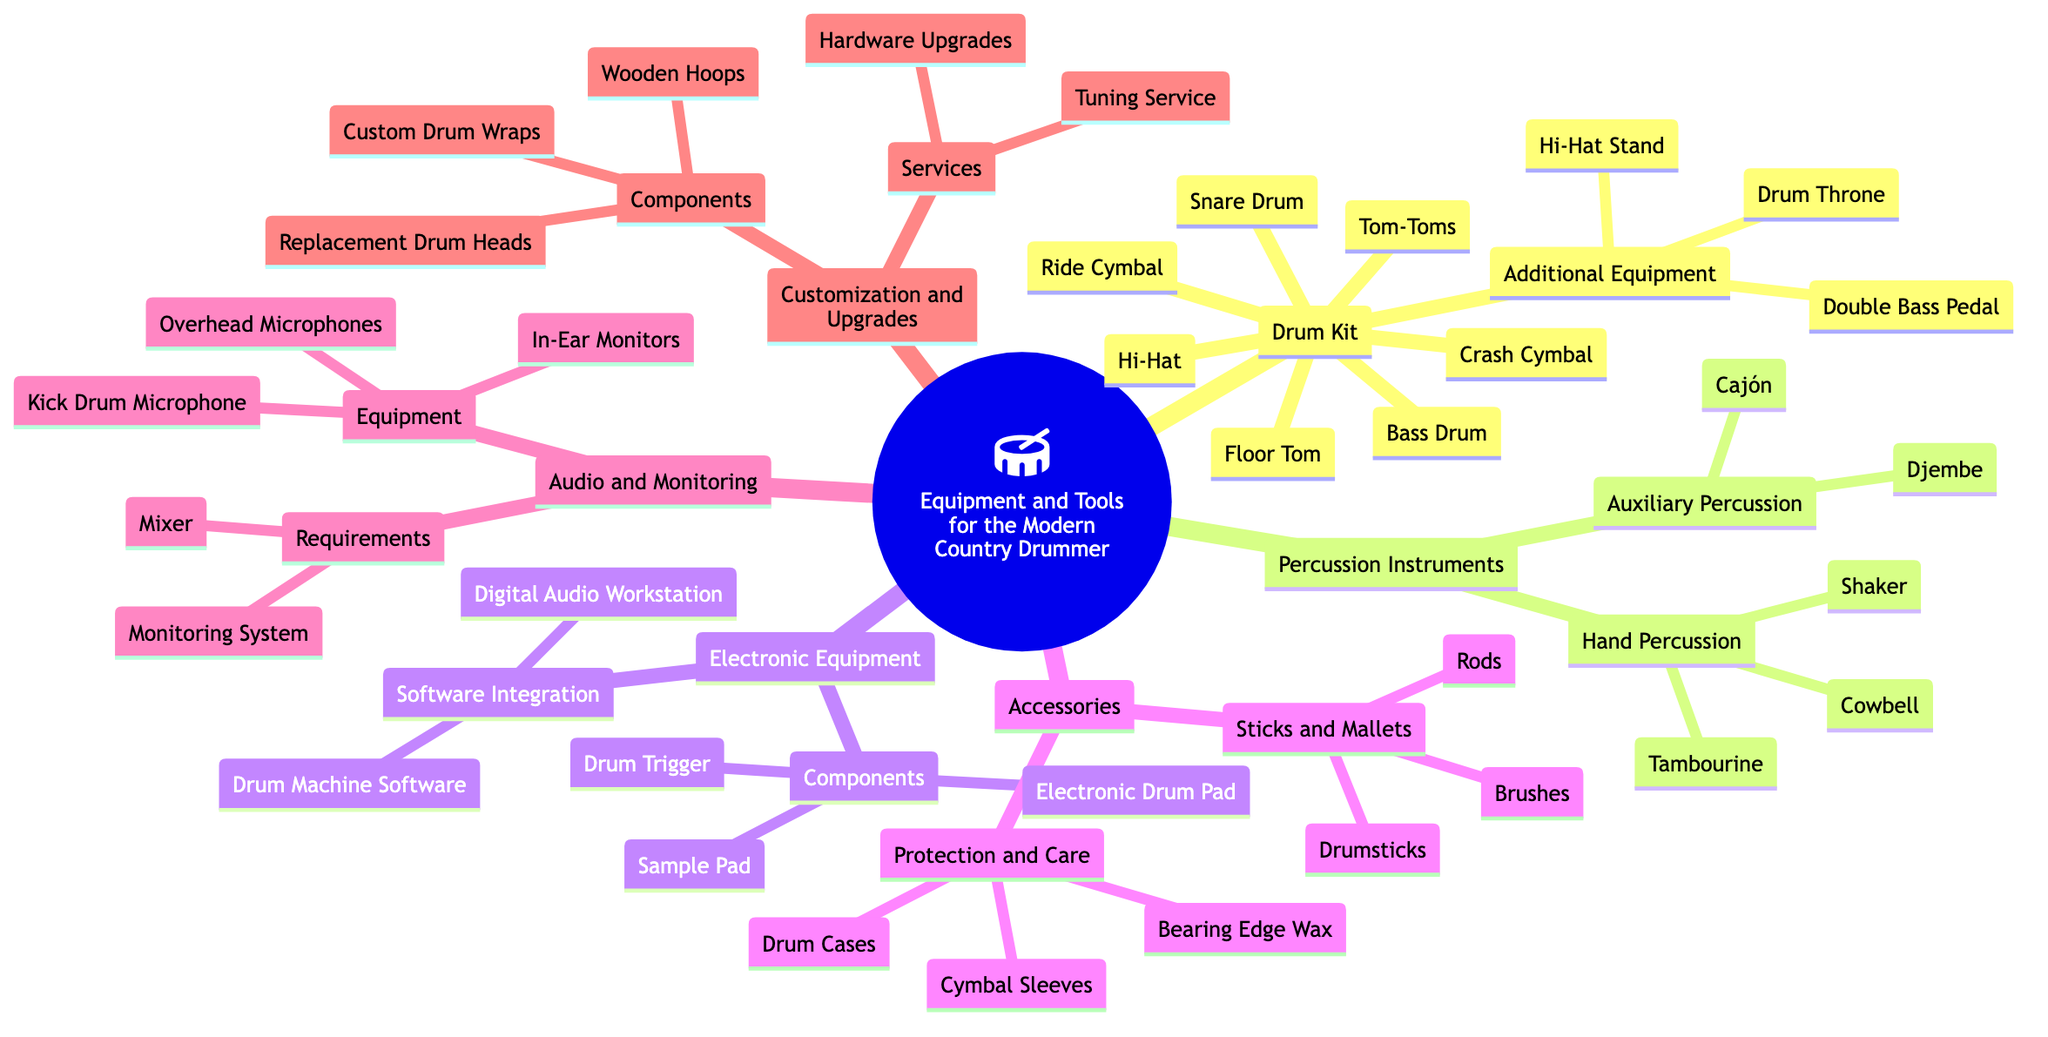What are the main categories of equipment listed in the mind map? The mind map lists "Drum Kit", "Percussion Instruments", "Electronic Equipment", "Accessories", "Audio and Monitoring", and "Customization and Upgrades" as main categories. These categories can be found as the primary nodes branching out from the root node.
Answer: Drum Kit, Percussion Instruments, Electronic Equipment, Accessories, Audio and Monitoring, Customization and Upgrades How many components are included in the "Drum Kit"? The "Drum Kit" sub-topic includes seven components: "Snare Drum", "Bass Drum", "Tom-Toms", "Hi-Hat", "Ride Cymbal", "Crash Cymbal", and "Floor Tom". By counting these items in the diagram, we can determine the total.
Answer: 7 What additional equipment is listed under the "Drum Kit"? The "Drum Kit" includes three additional items: "Double Bass Pedal", "Hi-Hat Stand", and "Drum Throne" as indicated under the sub-topic. This is a direct count of the items in that section.
Answer: Double Bass Pedal, Hi-Hat Stand, Drum Throne Which sub-topic includes "Cajón"? "Cajón" is listed under the "Auxiliary Percussion" section, which is a subset of the "Percussion Instruments" main category. To identify its location, we trace the branches down from the main topic to the specific item.
Answer: Auxiliary Percussion What types of audio equipment are mentioned in the mind map? The "Audio and Monitoring" sub-topic mentions "In-Ear Monitors", "Overhead Microphones", and "Kick Drum Microphone" under its equipment section. By reviewing this category, we can list the specific types.
Answer: In-Ear Monitors, Overhead Microphones, Kick Drum Microphone What services are mentioned under "Customization and Upgrades"? The services listed under "Customization and Upgrades" include "Tuning Service" and "Hardware Upgrades", as indicated in that section. This involves reading the items provided in the diagram directly under that sub-topic.
Answer: Tuning Service, Hardware Upgrades Which component is used for sound integration in the electronic section? The "Drum Machine Software" is part of the "Software Integration" category within the "Electronic Equipment" sub-topic. To find this, we look under the corresponding title in the diagram for the components listed.
Answer: Drum Machine Software How many hand percussion instruments are listed? Three hand percussion instruments are detailed: "Cowbell", "Shaker", and "Tambourine". The count requires the identification of each item listed under the "Hand Percussion" subsection in the mind map.
Answer: 3 